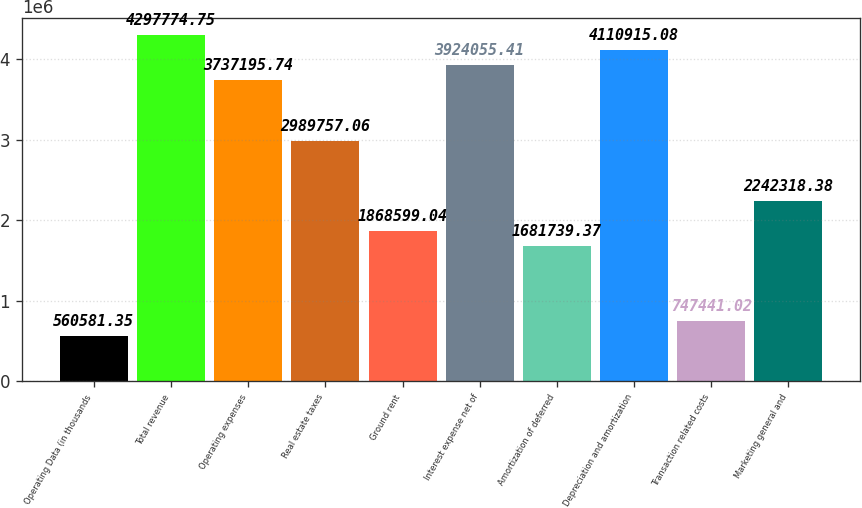Convert chart to OTSL. <chart><loc_0><loc_0><loc_500><loc_500><bar_chart><fcel>Operating Data (in thousands<fcel>Total revenue<fcel>Operating expenses<fcel>Real estate taxes<fcel>Ground rent<fcel>Interest expense net of<fcel>Amortization of deferred<fcel>Depreciation and amortization<fcel>Transaction related costs<fcel>Marketing general and<nl><fcel>560581<fcel>4.29777e+06<fcel>3.7372e+06<fcel>2.98976e+06<fcel>1.8686e+06<fcel>3.92406e+06<fcel>1.68174e+06<fcel>4.11092e+06<fcel>747441<fcel>2.24232e+06<nl></chart> 